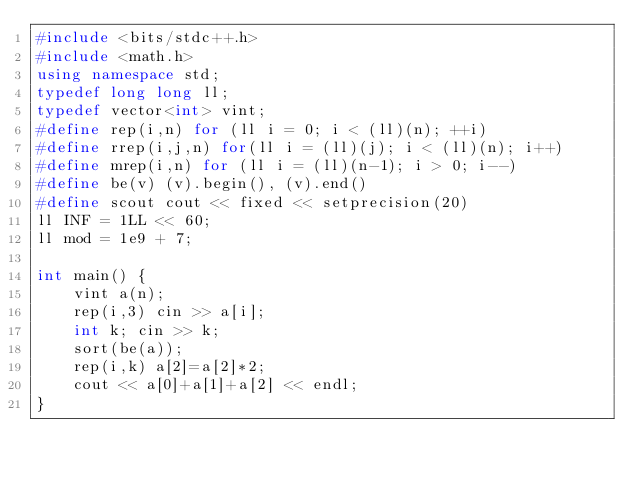Convert code to text. <code><loc_0><loc_0><loc_500><loc_500><_C++_>#include <bits/stdc++.h>
#include <math.h>
using namespace std;
typedef long long ll;
typedef vector<int> vint;
#define rep(i,n) for (ll i = 0; i < (ll)(n); ++i)
#define rrep(i,j,n) for(ll i = (ll)(j); i < (ll)(n); i++)
#define mrep(i,n) for (ll i = (ll)(n-1); i > 0; i--)
#define be(v) (v).begin(), (v).end()
#define scout cout << fixed << setprecision(20) 
ll INF = 1LL << 60;
ll mod = 1e9 + 7;

int main() {
	vint a(n);
	rep(i,3) cin >> a[i];
	int k; cin >> k;
	sort(be(a));
	rep(i,k) a[2]=a[2]*2;
	cout << a[0]+a[1]+a[2] << endl;
}
</code> 